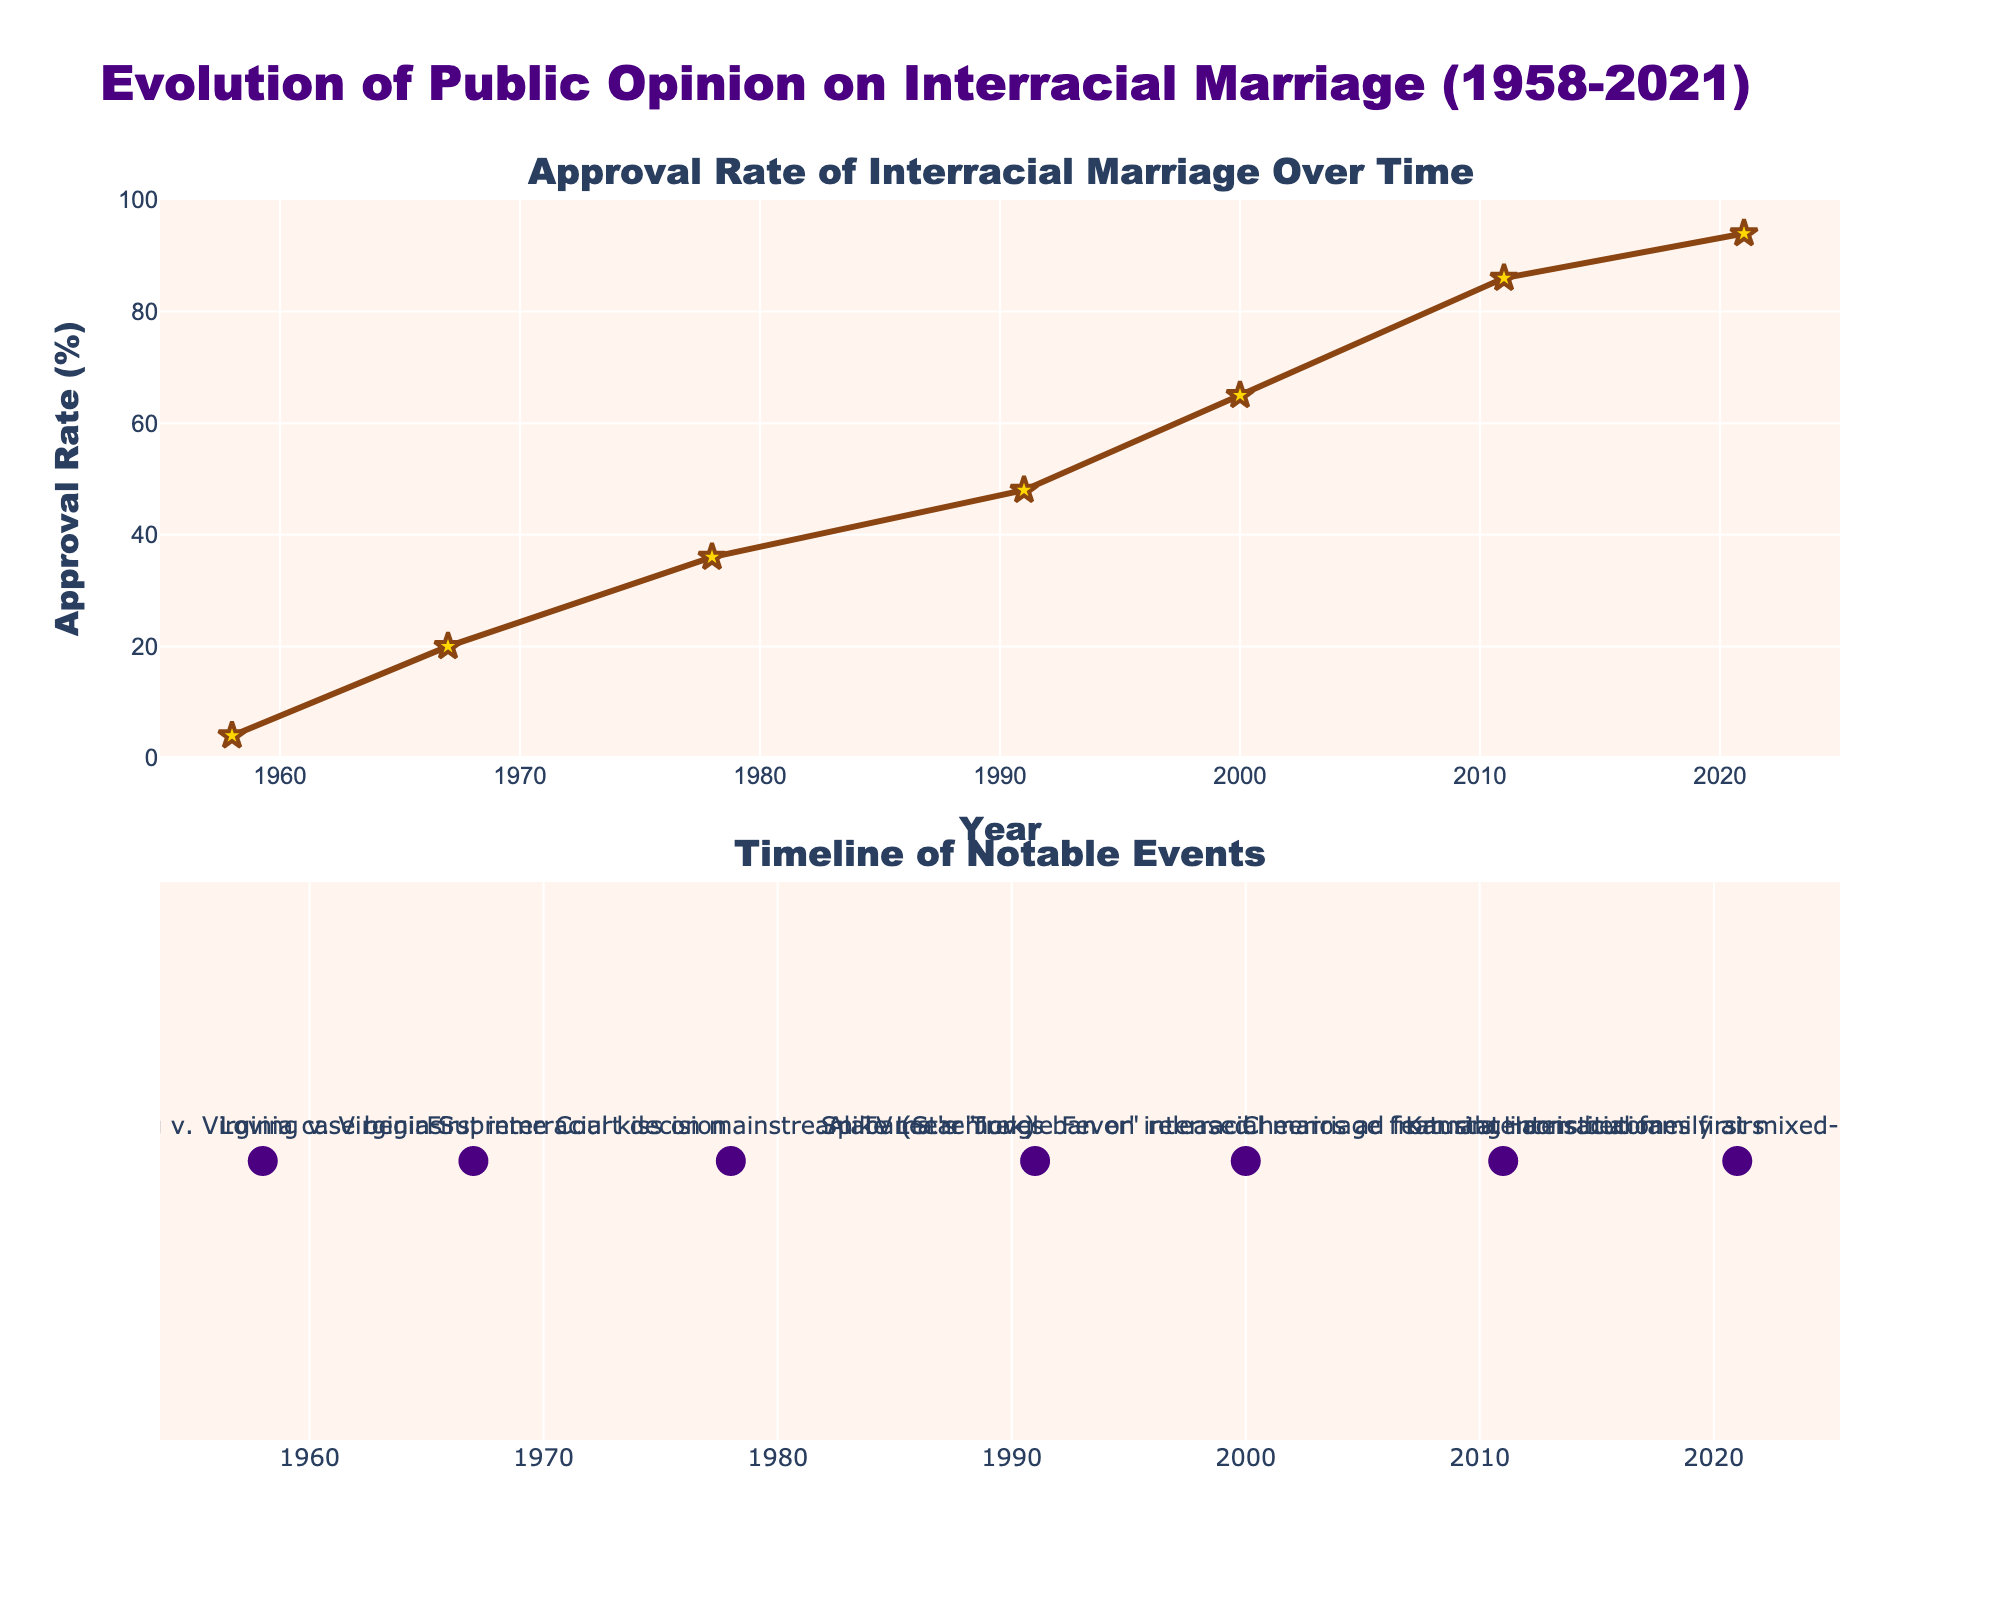What is the title of the plot? The title of the plot is shown at the top of the figure and it reads "Evolution of Public Opinion on Interracial Marriage (1958-2021)".
Answer: Evolution of Public Opinion on Interracial Marriage (1958-2021) What is the approval rate of interracial marriage in the year 1958? By looking at the y-axis value corresponding to the year 1958 on the first subplot, the approval rate of interracial marriage in 1958 is 4%.
Answer: 4% How many notable events are displayed in the second subplot? Counting the number of markers in the second subplot (located at the bottom of the figure) indicates that there are 7 notable events displayed.
Answer: 7 Which notable event happened in 1967, and what was the approval rate of interracial marriage that year? The notable event in 1967 as indicated in the second subplot is the Loving v. Virginia Supreme Court decision, and from the first subplot, the approval rate of interracial marriage was 20% in 1967.
Answer: Loving v. Virginia Supreme Court decision, 20% By how many percentage points did the approval rate increase between 1958 and 1978? The approval rate in 1958 was 4%, and in 1978, it was 36%. To find the increase, subtract the 1958 value from the 1978 value: 36% - 4% = 32%.
Answer: 32% Which year in the plot shows the largest approval rate of interracial marriage, and what is the rate? The year 2021 shows the largest approval rate of interracial marriage at 94%, as indicated by the highest data point on the first subplot.
Answer: 2021, 94% Did the approval rate of interracial marriage increase or decrease between 1991 and 2000, and by how much? The approval rate in 1991 was 48%, and in 2000, it was 65%. To determine the change, subtract the 1991 value from the 2000 value: 65% - 48% = 17%. The approval rate increased.
Answer: Increased, 17% What notable event is associated with the year 2011 and what is the approval rate that year? The notable event in 2011, as indicated in the second subplot, is the airing of a Cheerios ad featuring an interracial family. The approval rate of interracial marriage for that year is 86% as seen on the first subplot.
Answer: Cheerios ad featuring interracial family airs, 86% What is the median approval rate of interracial marriage based on the available data points? Arranging the approval rates in ascending order: 4%, 20%, 36%, 48%, 65%, 86%, and 94%, the median value is the middle element of this sorted list, which is the 4th element, 48%.
Answer: 48% 